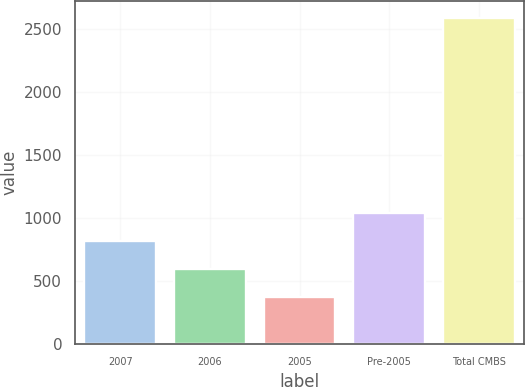Convert chart to OTSL. <chart><loc_0><loc_0><loc_500><loc_500><bar_chart><fcel>2007<fcel>2006<fcel>2005<fcel>Pre-2005<fcel>Total CMBS<nl><fcel>815.6<fcel>594.3<fcel>373<fcel>1036.9<fcel>2586<nl></chart> 